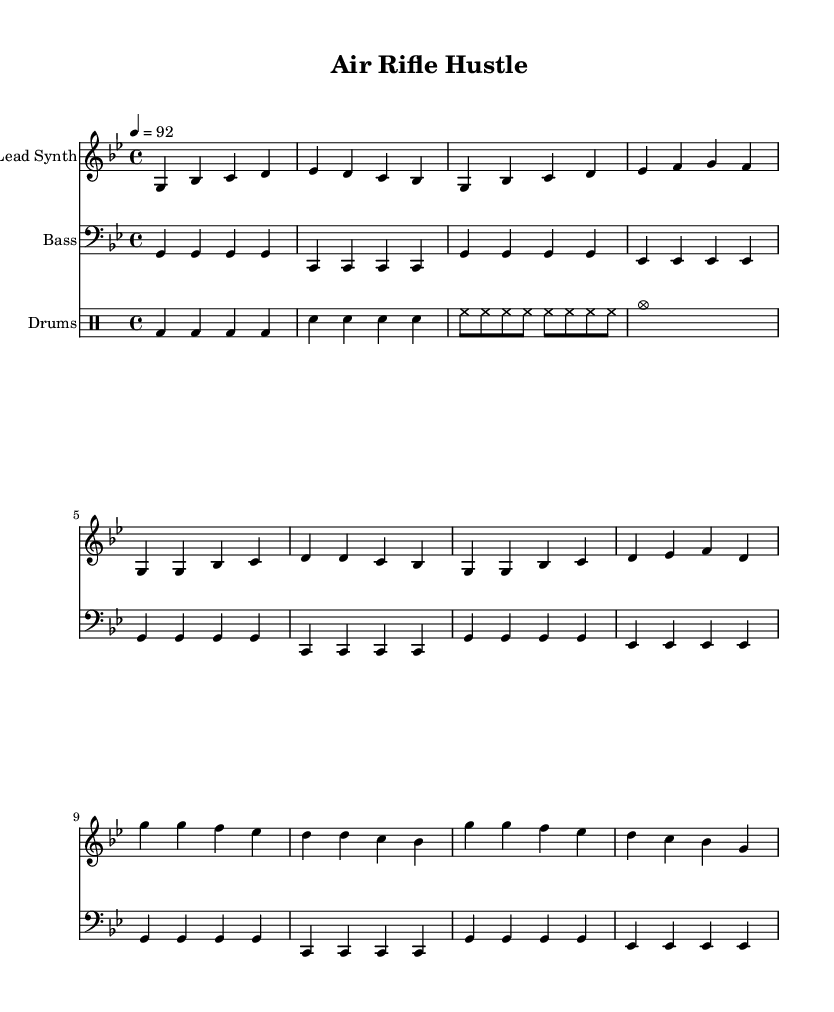What is the key signature of this music? The key signature is G minor, which has two flats: B flat and E flat. This can be determined by looking at the key signature symbol at the beginning of the staff in the sheet music.
Answer: G minor What is the time signature of this music? The time signature is 4/4, which is indicated at the beginning of the score. This means there are four beats in each measure and the quarter note receives one beat.
Answer: 4/4 What is the tempo marking of this piece? The tempo marking is 92 BPM (beats per minute), specified at the beginning of the score. This indicates the speed at which the piece should be performed.
Answer: 92 How many measures are in the intro section? The intro section consists of four measures as indicated by the arrangement of the notes and rests in that portion of the score.
Answer: 4 What type of musical instruments are featured in this piece? The piece features a lead synth, a bass, and drums, as indicated by their respective staff labels. Each section is clearly defined in the score.
Answer: Lead synth, bass, and drums Which section follows the intro in the structure? The structure shows that the verse follows the intro, as indicated by the flow of the music notations. Typically, in music composition, verses occur after introductory sections.
Answer: Verse What genre does this piece belong to? The genre is identified as Hip Hop, as inferred from the thematic content of the lyrics suggested in the description and the musical style aligned with Hip Hop dynamics.
Answer: Hip Hop 